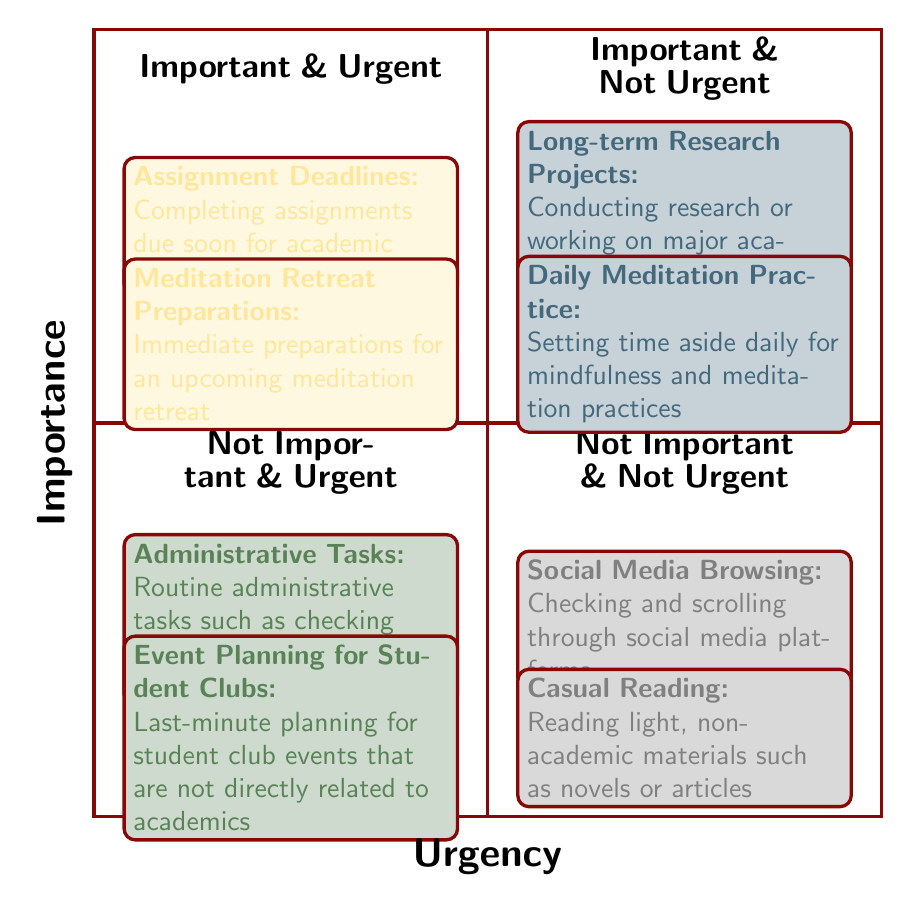What's in the "Important & Urgent" quadrant? The "Important & Urgent" quadrant includes two items: "Assignment Deadlines" and "Meditation Retreat Preparations." These items are prioritized due to their immediacy and significance.
Answer: Assignment Deadlines, Meditation Retreat Preparations How many items are in the "Not Important & Not Urgent" quadrant? The "Not Important & Not Urgent" quadrant contains two items: "Social Media Browsing" and "Casual Reading." Counting these gives a total of two items.
Answer: 2 Which activity focuses on long-term efforts? The activity located in the "Important & Not Urgent" quadrant is "Long-term Research Projects." This focuses on extended efforts essential for future success.
Answer: Long-term Research Projects What is the primary difference between the "Important & Urgent" and "Not Important & Urgent" quadrants? The primary difference is that the "Important & Urgent" quadrant contains activities that contribute significantly to academic or personal growth, whereas the "Not Important & Urgent" quadrant focuses on less significant routine tasks that demand immediate attention.
Answer: Significance of activities What types of activities are found in the "Not Important & Not Urgent" category? The "Not Important & Not Urgent" category contains activities that do not significantly contribute to personal or academic development, such as leisure activities. The specific activities listed are "Social Media Browsing" and "Casual Reading."
Answer: Social Media Browsing, Casual Reading 